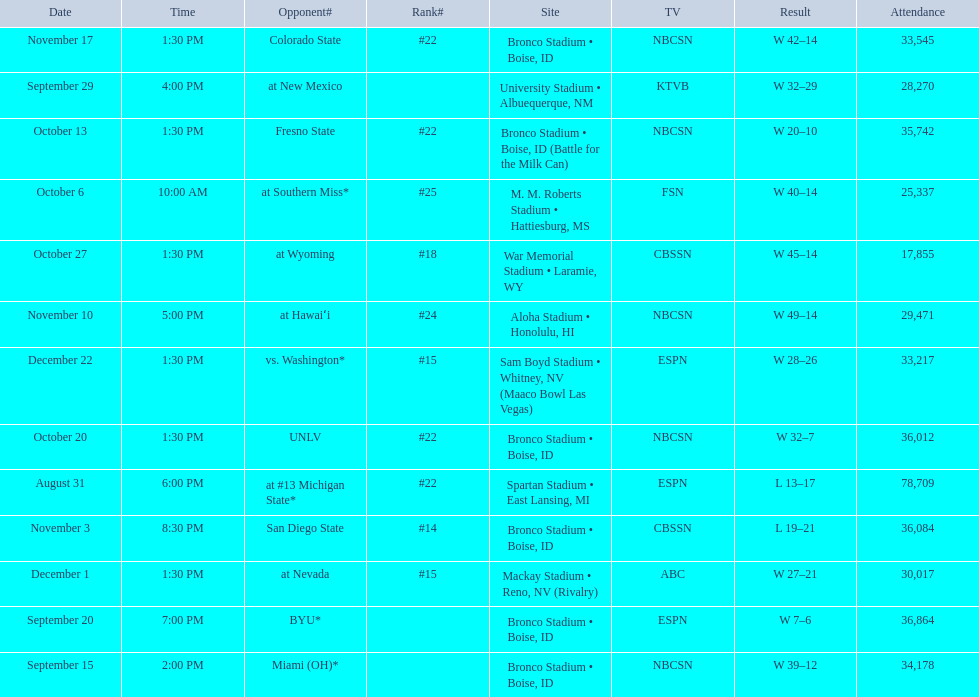What was there top ranked position of the season? #14. 